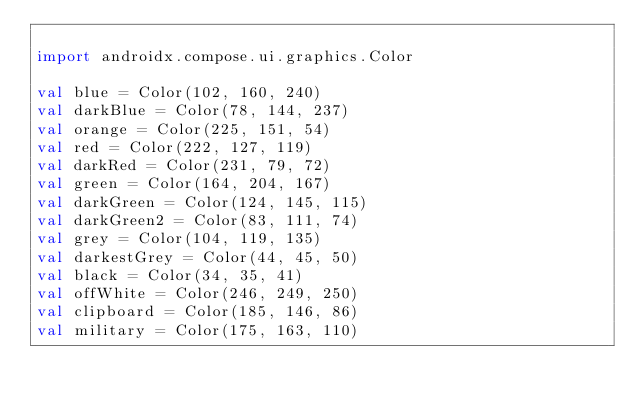Convert code to text. <code><loc_0><loc_0><loc_500><loc_500><_Kotlin_>
import androidx.compose.ui.graphics.Color

val blue = Color(102, 160, 240)
val darkBlue = Color(78, 144, 237)
val orange = Color(225, 151, 54)
val red = Color(222, 127, 119)
val darkRed = Color(231, 79, 72)
val green = Color(164, 204, 167)
val darkGreen = Color(124, 145, 115)
val darkGreen2 = Color(83, 111, 74)
val grey = Color(104, 119, 135)
val darkestGrey = Color(44, 45, 50)
val black = Color(34, 35, 41)
val offWhite = Color(246, 249, 250)
val clipboard = Color(185, 146, 86)
val military = Color(175, 163, 110)
</code> 